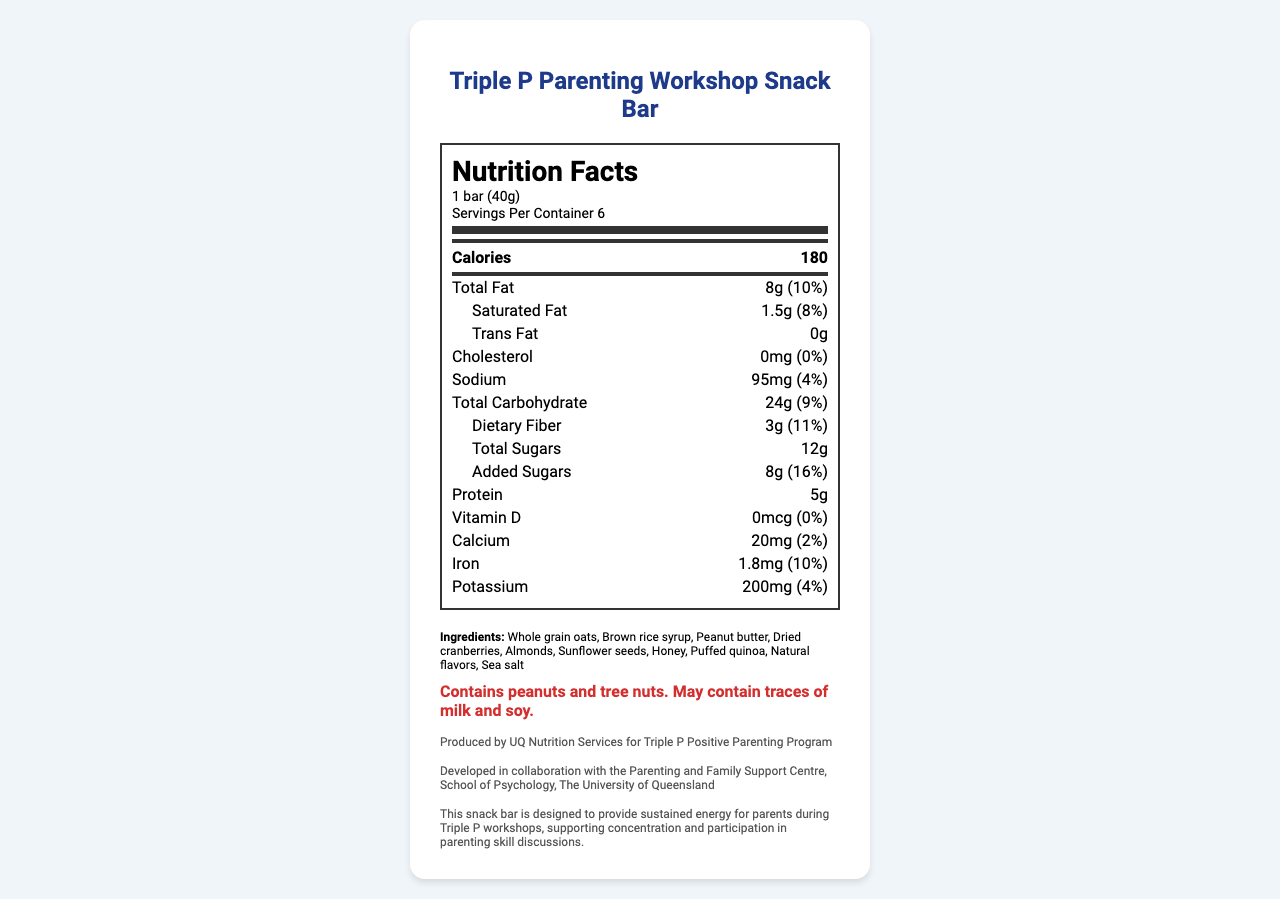what is the serving size? The serving size is mentioned under the "Nutrition Facts" section right at the beginning.
Answer: 1 bar (40g) how many calories are in one bar? The calorie count is displayed prominently in the nutrition facts panel beside the label "Calories."
Answer: 180 calories what is the total fat content per serving? The total fat per serving is listed in the nutrition facts section next to "Total Fat."
Answer: 8g what is the amount of dietary fiber per serving? The dietary fiber content is listed under the "Total Carbohydrate" section as "Dietary Fiber."
Answer: 3g what percentage of the daily value is provided by added sugars? The daily value for added sugars is provided next to "Added Sugars" in the nutrition facts section.
Answer: 16% what ingredients are included in the snack bar? The ingredients are listed under the "Ingredients" section towards the bottom of the document.
Answer: Whole grain oats, Brown rice syrup, Peanut butter, Dried cranberries, Almonds, Sunflower seeds, Honey, Puffed quinoa, Natural flavors, Sea salt how many servings are there per container? The number of servings per container is mentioned right under the serving size in the nutrition facts section.
Answer: 6 how much iron is in the snack bar? The amount of iron per serving is listed in the nutrition facts section as "Iron."
Answer: 1.8mg what is the amount of protein per serving? The protein content per serving is mentioned in the nutrition facts section as "Protein."
Answer: 5g what are the allergens present in the snack bar? The allergen information is provided in a bold red font under the "Allergen info" section.
Answer: Contains peanuts and tree nuts. May contain traces of milk and soy. how much sodium does one snack bar contain? A. 50mg B. 95mg C. 100mg D. 150mg The sodium content per serving is listed under the "Sodium" section in the nutrition facts.
Answer: B. 95mg which of the following minerals is NOT mentioned in the nutrition facts? I. Vitamin D II. Zinc III. Iron IV. Calcium Vitamin D, Iron, and Calcium are listed in the nutrition facts section, while Zinc is not mentioned.
Answer: II. Zinc does the snack bar contain trans fats? The trans fats content is listed as "0g" under the "Trans Fat" section in the nutrition facts.
Answer: No is vitamin D present in the snack bar? The amount of Vitamin D is listed as "0mcg" in the nutrition facts section.
Answer: No what is the document about? This main idea is derived by summarizing the contents, which include the nutritional details, ingredients list, allergen information, and the context in which the snack bar is used.
Answer: The document provides the nutrition facts, ingredients, allergen information, and manufacturer details for the "Triple P Parenting Workshop Snack Bar." It also mentions the relevance of the snack bar for Triple P workshops. which flavor does the snack bar have? The document does not provide any information regarding the flavor of the snack bar, so it's not possible to answer based on the available visual information.
Answer: Cannot be determined 